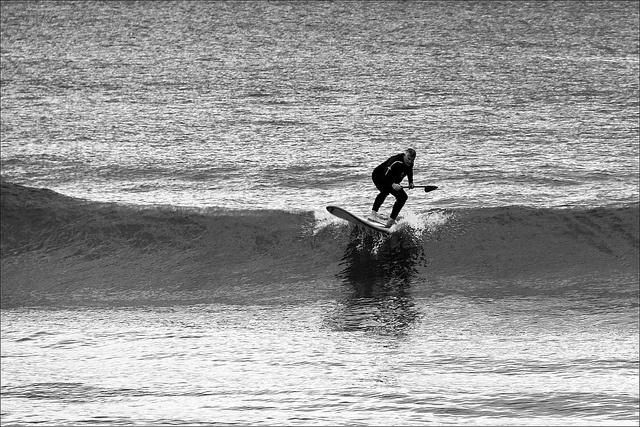Describe the objects in this image and their specific colors. I can see people in black, gray, darkgray, and lightgray tones and surfboard in black, gray, darkgray, and lightgray tones in this image. 